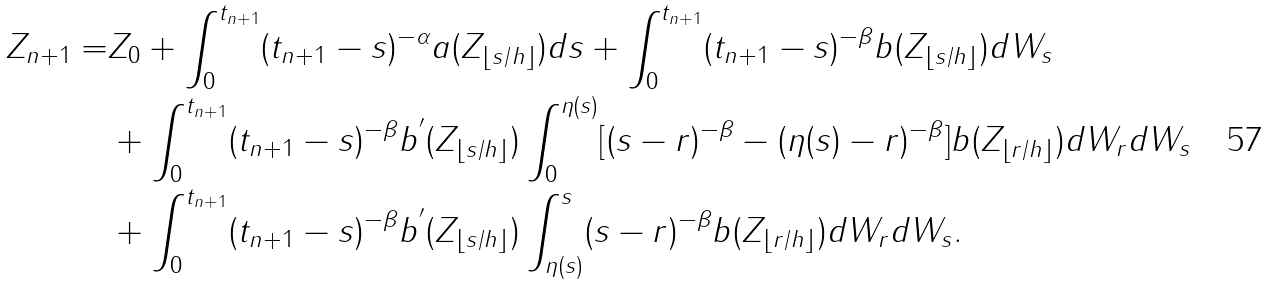Convert formula to latex. <formula><loc_0><loc_0><loc_500><loc_500>Z _ { n + 1 } = & Z _ { 0 } + \int _ { 0 } ^ { t _ { n + 1 } } ( t _ { n + 1 } - s ) ^ { - \alpha } a ( Z _ { \lfloor s / h \rfloor } ) d s + \int _ { 0 } ^ { t _ { n + 1 } } ( t _ { n + 1 } - s ) ^ { - \beta } b ( Z _ { \lfloor s / h \rfloor } ) d W _ { s } \\ & + \int _ { 0 } ^ { t _ { n + 1 } } ( t _ { n + 1 } - s ) ^ { - \beta } b ^ { ^ { \prime } } ( Z _ { \lfloor s / h \rfloor } ) \int _ { 0 } ^ { \eta ( s ) } [ ( s - r ) ^ { - \beta } - ( \eta ( s ) - r ) ^ { - \beta } ] b ( Z _ { \lfloor r / h \rfloor } ) d W _ { r } d W _ { s } \\ & + \int _ { 0 } ^ { t _ { n + 1 } } ( t _ { n + 1 } - s ) ^ { - \beta } b ^ { ^ { \prime } } ( Z _ { \lfloor s / h \rfloor } ) \int _ { \eta ( s ) } ^ { s } ( s - r ) ^ { - \beta } b ( Z _ { \lfloor r / h \rfloor } ) d W _ { r } d W _ { s } .</formula> 